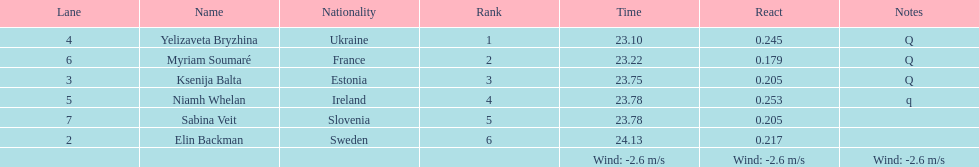Would you be able to parse every entry in this table? {'header': ['Lane', 'Name', 'Nationality', 'Rank', 'Time', 'React', 'Notes'], 'rows': [['4', 'Yelizaveta Bryzhina', 'Ukraine', '1', '23.10', '0.245', 'Q'], ['6', 'Myriam Soumaré', 'France', '2', '23.22', '0.179', 'Q'], ['3', 'Ksenija Balta', 'Estonia', '3', '23.75', '0.205', 'Q'], ['5', 'Niamh Whelan', 'Ireland', '4', '23.78', '0.253', 'q'], ['7', 'Sabina Veit', 'Slovenia', '5', '23.78', '0.205', ''], ['2', 'Elin Backman', 'Sweden', '6', '24.13', '0.217', ''], ['', '', '', '', 'Wind: -2.6\xa0m/s', 'Wind: -2.6\xa0m/s', 'Wind: -2.6\xa0m/s']]} What number of last names start with "b"? 3. 